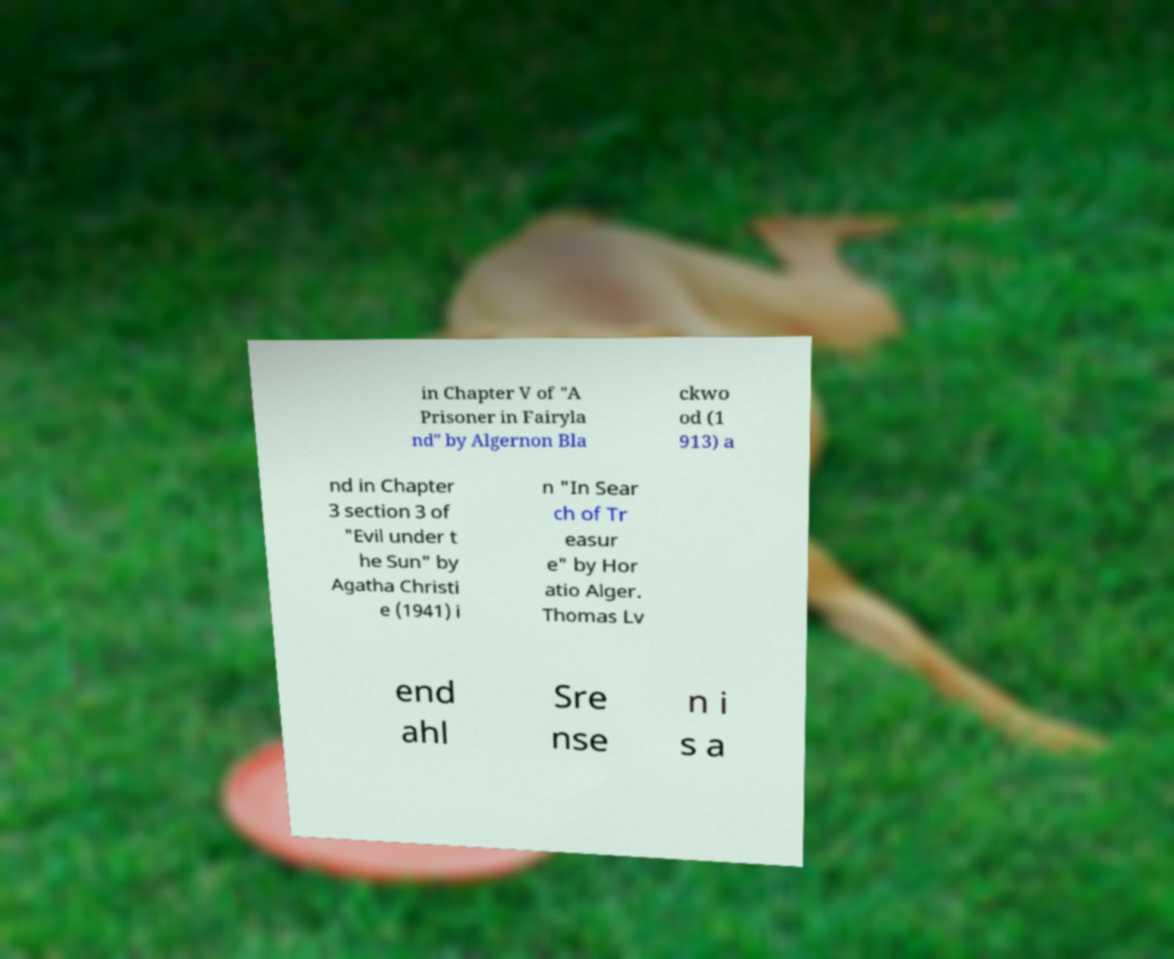There's text embedded in this image that I need extracted. Can you transcribe it verbatim? in Chapter V of "A Prisoner in Fairyla nd" by Algernon Bla ckwo od (1 913) a nd in Chapter 3 section 3 of "Evil under t he Sun" by Agatha Christi e (1941) i n "In Sear ch of Tr easur e" by Hor atio Alger. Thomas Lv end ahl Sre nse n i s a 